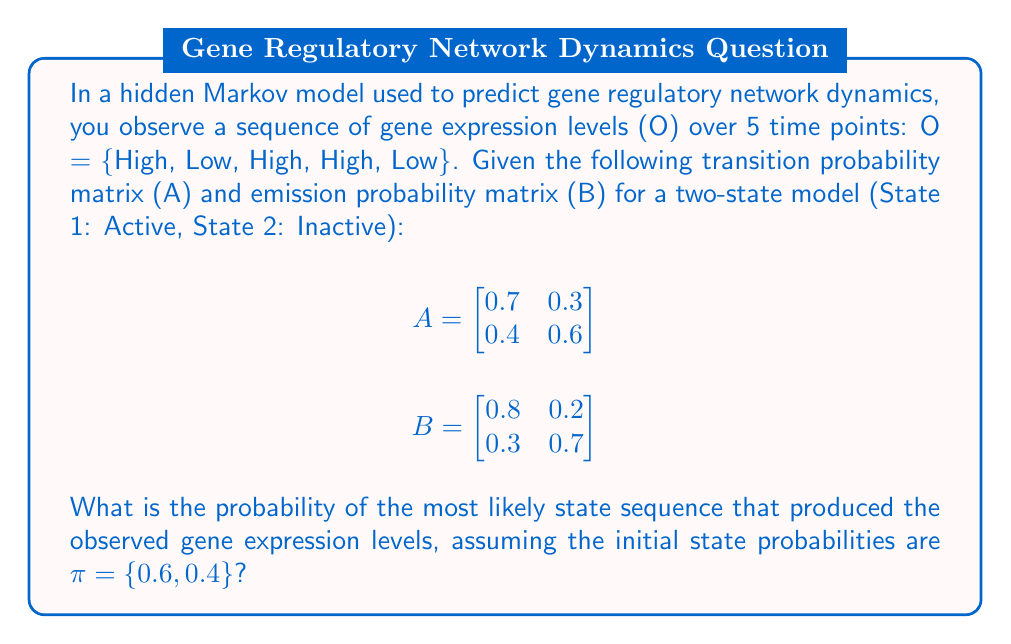Can you solve this math problem? To solve this problem, we'll use the Viterbi algorithm, which finds the most probable sequence of hidden states given the observed sequence.

Step 1: Initialize the Viterbi matrix V and a traceback matrix T.

$$V_{1,1} = 0.6 \times 0.8 = 0.48$$
$$V_{2,1} = 0.4 \times 0.3 = 0.12$$

Step 2: Fill in the Viterbi matrix for t = 2 to 5.

For t = 2 (Low):
$$V_{1,2} = \max(0.48 \times 0.7, 0.12 \times 0.4) \times 0.2 = 0.0672$$
$$V_{2,2} = \max(0.48 \times 0.3, 0.12 \times 0.6) \times 0.7 = 0.1008$$

For t = 3 (High):
$$V_{1,3} = \max(0.0672 \times 0.7, 0.1008 \times 0.4) \times 0.8 = 0.03763$$
$$V_{2,3} = \max(0.0672 \times 0.3, 0.1008 \times 0.6) \times 0.3 = 0.01814$$

For t = 4 (High):
$$V_{1,4} = \max(0.03763 \times 0.7, 0.01814 \times 0.4) \times 0.8 = 0.02106$$
$$V_{2,4} = \max(0.03763 \times 0.3, 0.01814 \times 0.6) \times 0.3 = 0.00340$$

For t = 5 (Low):
$$V_{1,5} = \max(0.02106 \times 0.7, 0.00340 \times 0.4) \times 0.2 = 0.00295$$
$$V_{2,5} = \max(0.02106 \times 0.3, 0.00340 \times 0.6) \times 0.7 = 0.00441$$

Step 3: Find the most likely end state and trace back to find the most likely sequence.

The most likely end state is State 2 (0.00441 > 0.00295).
Tracing back, we get the most likely state sequence: {1, 2, 1, 1, 2}.

Step 4: Calculate the probability of this sequence.

$$P = 0.6 \times 0.8 \times 0.3 \times 0.7 \times 0.7 \times 0.8 \times 0.7 \times 0.8 \times 0.3 \times 0.7 = 0.00441$$
Answer: 0.00441 